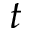<formula> <loc_0><loc_0><loc_500><loc_500>t</formula> 